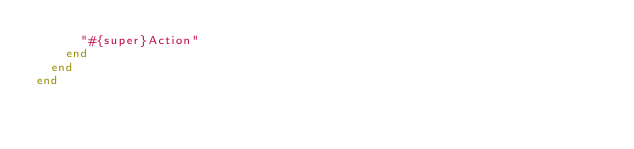<code> <loc_0><loc_0><loc_500><loc_500><_Ruby_>      "#{super}Action"
    end
  end
end
</code> 